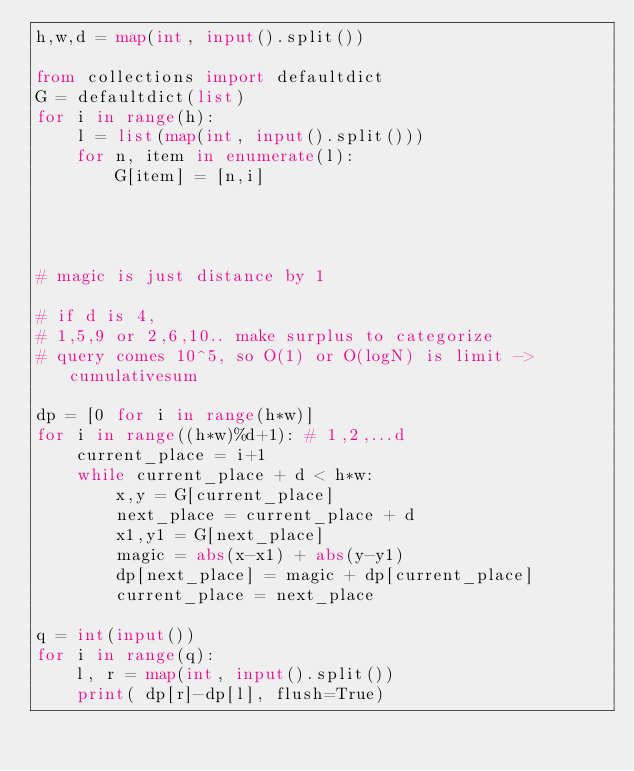<code> <loc_0><loc_0><loc_500><loc_500><_Python_>h,w,d = map(int, input().split())

from collections import defaultdict
G = defaultdict(list)
for i in range(h):
    l = list(map(int, input().split()))
    for n, item in enumerate(l):
        G[item] = [n,i]




# magic is just distance by 1

# if d is 4,
# 1,5,9 or 2,6,10.. make surplus to categorize
# query comes 10^5, so O(1) or O(logN) is limit -> cumulativesum

dp = [0 for i in range(h*w)]
for i in range((h*w)%d+1): # 1,2,...d
    current_place = i+1
    while current_place + d < h*w:
        x,y = G[current_place]
        next_place = current_place + d
        x1,y1 = G[next_place]
        magic = abs(x-x1) + abs(y-y1)
        dp[next_place] = magic + dp[current_place]
        current_place = next_place

q = int(input())
for i in range(q):
    l, r = map(int, input().split())
    print( dp[r]-dp[l], flush=True)

</code> 